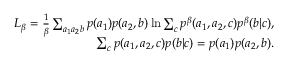<formula> <loc_0><loc_0><loc_500><loc_500>\begin{array} { r l r } & { L _ { \beta } = \frac { 1 } { \beta } \sum _ { a _ { 1 } a _ { 2 } b } p ( a _ { 1 } ) p ( a _ { 2 } , b ) \ln \sum _ { c } p ^ { \beta } ( a _ { 1 } , a _ { 2 } , c ) p ^ { \beta } ( b | c ) , } \\ & { \sum _ { c } p ( a _ { 1 } , a _ { 2 } , c ) p ( b | c ) = p ( a _ { 1 } ) p ( a _ { 2 } , b ) . } \end{array}</formula> 